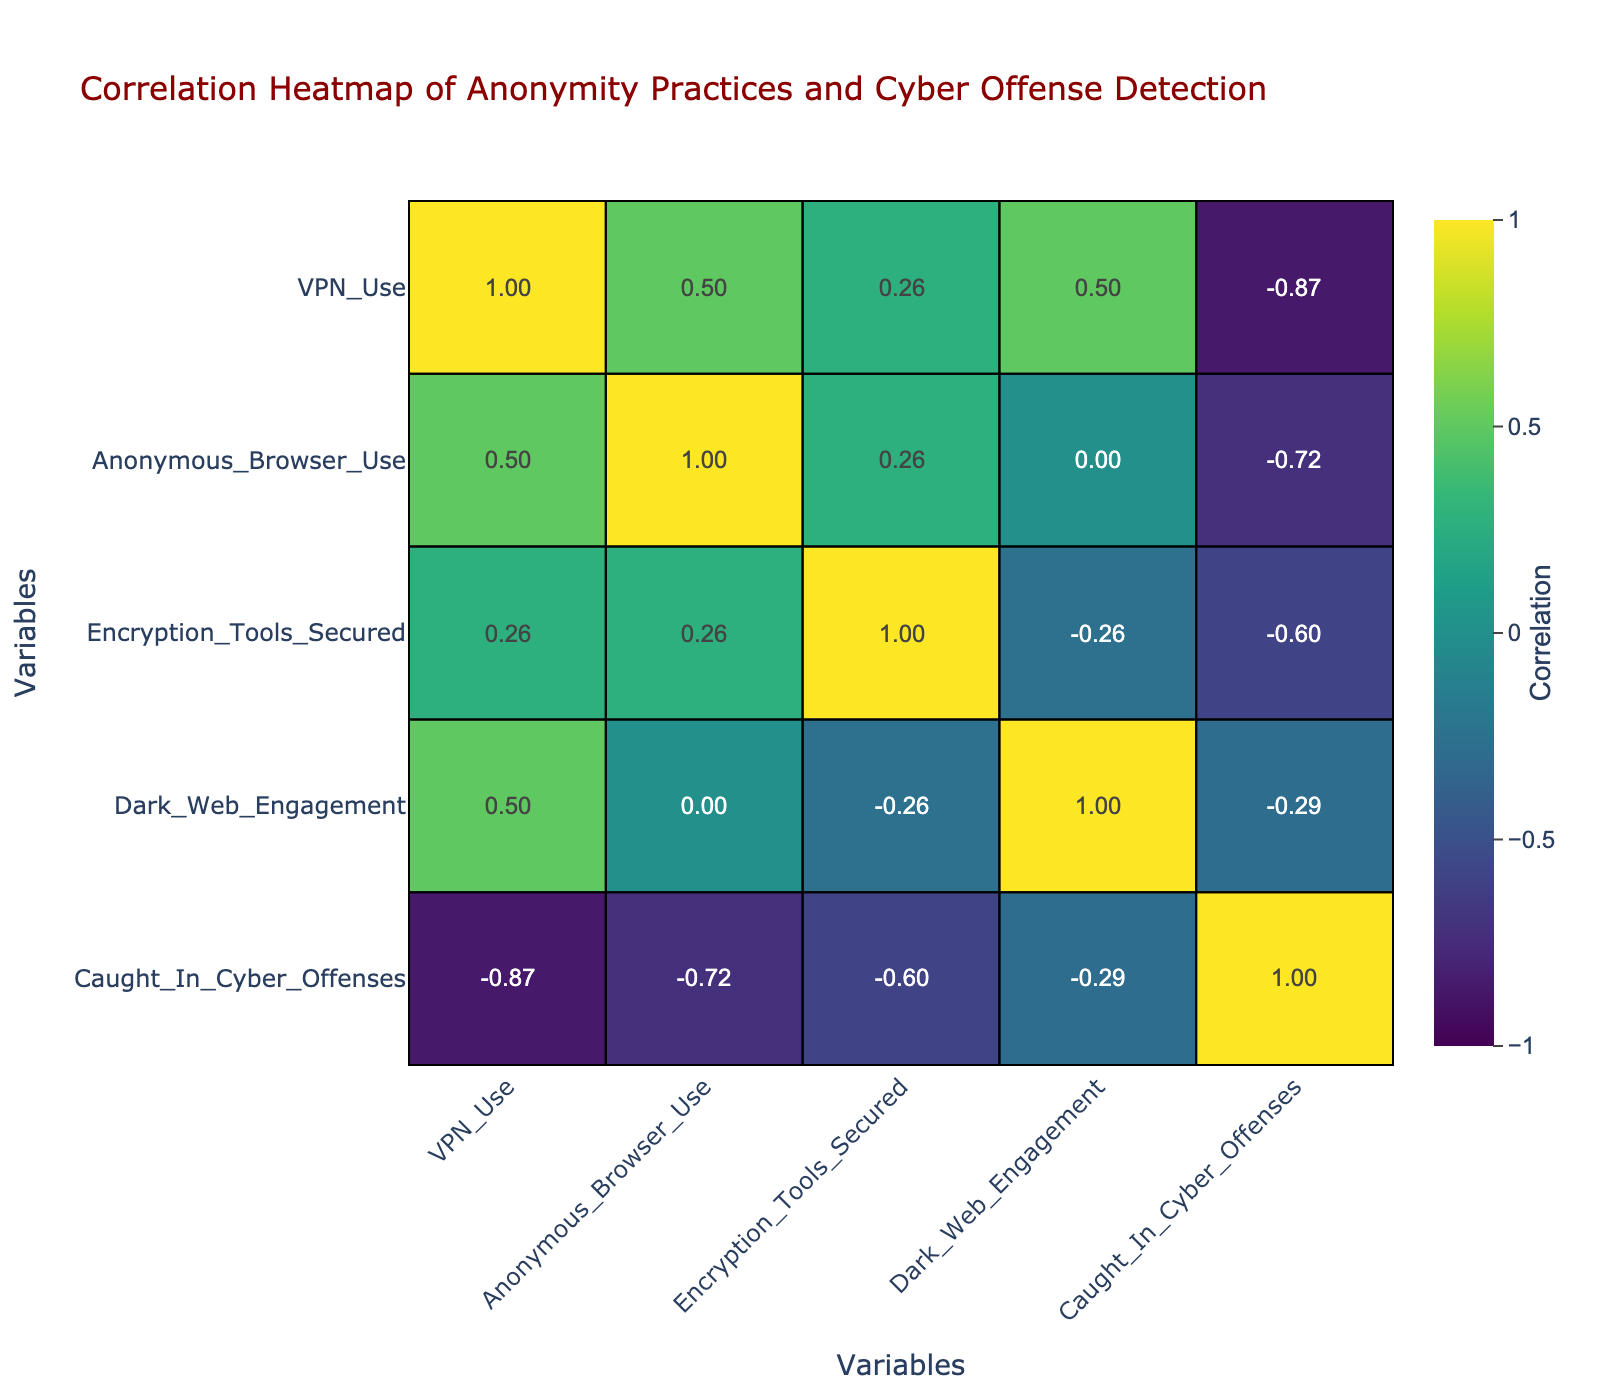What is the value of the correlation between VPN use and getting caught in cyber offenses? In the correlation table, we look for the row for VPN use and find the column for caught in cyber offenses. The value at that intersection indicates a correlation of -0.29.
Answer: -0.29 Is there a positive correlation between anonymous browser use and getting caught in cyber offenses? We check the correlation for anonymous browser use and caught in cyber offenses. The value is 0.24, which is positive but weak. Therefore, the statement is true.
Answer: Yes What is the average likelihood of getting caught in cyber offenses for those with High online anonymity practices? We identify the rows with High anonymity practices and look at the caught in cyber offenses values: 0, 1, and 0. The average is (0 + 1 + 0) / 3 = 0.33.
Answer: 0.33 How many total cases resulted in being caught in cyber offenses from Low anonymity practices? We count all cases with Low anonymity practices and the corresponding caught values: 5, 3, which gives us a total of 8 cases caught in cyber offenses.
Answer: 8 What is the correlation between Dark Web engagement and getting caught in cyber offenses? By examining the correlation table, check the row for Dark Web engagement and find the column for caught in cyber offenses, resulting in a correlation of 0.15.
Answer: 0.15 Is using encryption tools secured negatively correlated with being caught in cyber offenses? We find the correlation value between encryption tools secured and getting caught in cyber offenses, which is -0.21. This indicates a slight negative correlation, making the statement true.
Answer: Yes Which online anonymity practice shows the highest correlation with being caught in cyber offenses? To find this, we need the correlation values for each anonymity practice. The Medium practice shows the highest correlation with getting caught at 0.33.
Answer: Medium What is the total number of people who were caught among all practices? We add up the caught in cyber offenses values for each row: 0 + 1 + 5 + 2 + 1 + 3 + 0 + 4 = 16.
Answer: 16 What is the difference in the likelihood of getting caught in cyber offenses between those using high and low anonymity practices? For high anonymity practices, the caught values average to 0.33 (0, 1, 0) and for low anonymity practices, it averages to 4 (5, 3). The difference is 4 - 0.33 = 3.67.
Answer: 3.67 